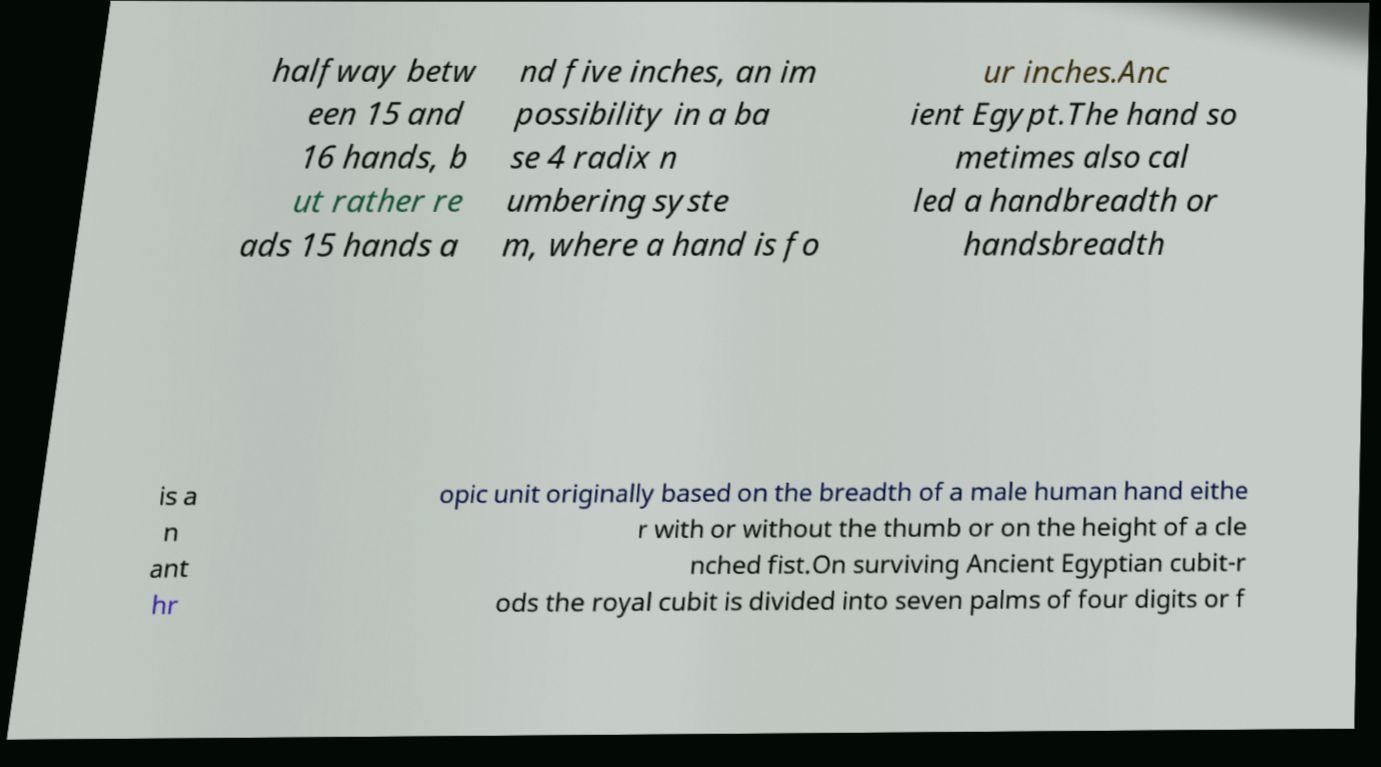What messages or text are displayed in this image? I need them in a readable, typed format. halfway betw een 15 and 16 hands, b ut rather re ads 15 hands a nd five inches, an im possibility in a ba se 4 radix n umbering syste m, where a hand is fo ur inches.Anc ient Egypt.The hand so metimes also cal led a handbreadth or handsbreadth is a n ant hr opic unit originally based on the breadth of a male human hand eithe r with or without the thumb or on the height of a cle nched fist.On surviving Ancient Egyptian cubit-r ods the royal cubit is divided into seven palms of four digits or f 